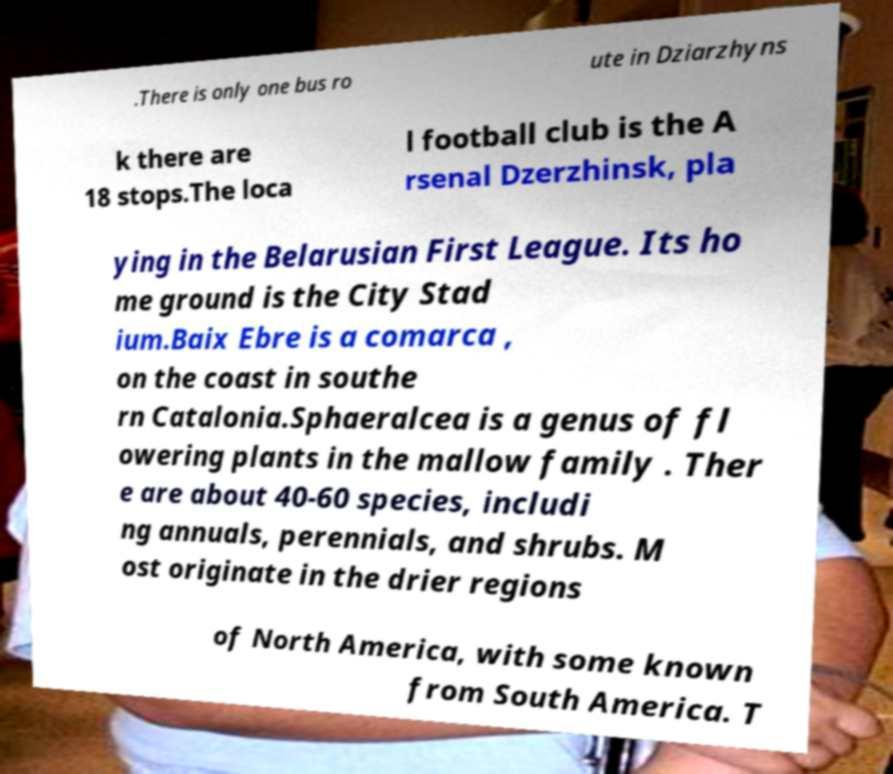Could you extract and type out the text from this image? .There is only one bus ro ute in Dziarzhyns k there are 18 stops.The loca l football club is the A rsenal Dzerzhinsk, pla ying in the Belarusian First League. Its ho me ground is the City Stad ium.Baix Ebre is a comarca , on the coast in southe rn Catalonia.Sphaeralcea is a genus of fl owering plants in the mallow family . Ther e are about 40-60 species, includi ng annuals, perennials, and shrubs. M ost originate in the drier regions of North America, with some known from South America. T 